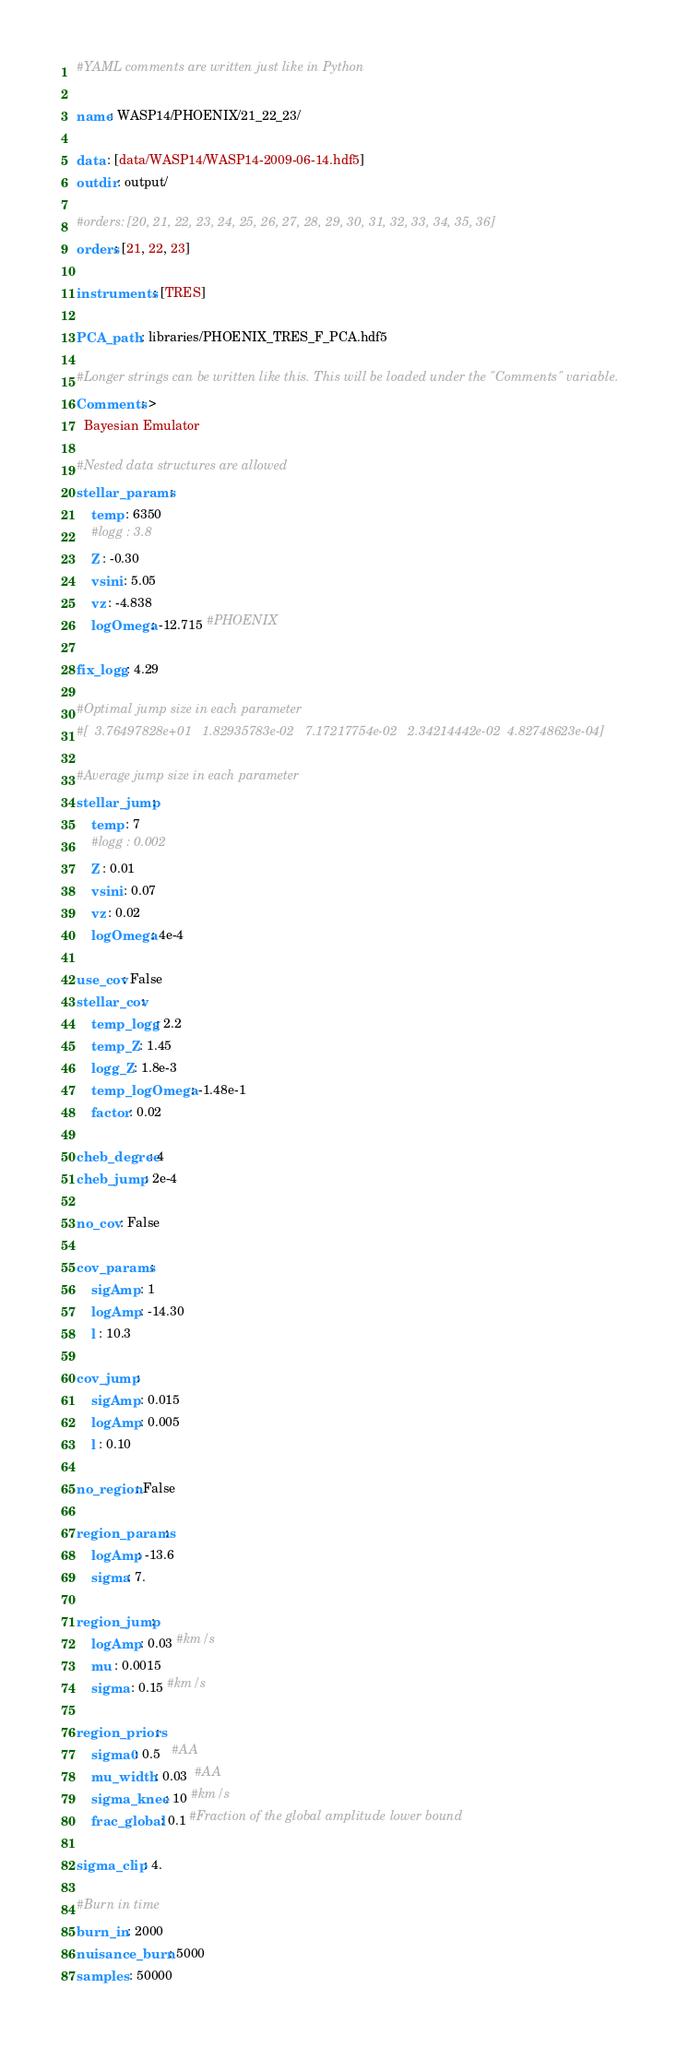<code> <loc_0><loc_0><loc_500><loc_500><_YAML_>#YAML comments are written just like in Python

name: WASP14/PHOENIX/21_22_23/

data : [data/WASP14/WASP14-2009-06-14.hdf5]
outdir : output/

#orders: [20, 21, 22, 23, 24, 25, 26, 27, 28, 29, 30, 31, 32, 33, 34, 35, 36]
orders: [21, 22, 23]

instruments : [TRES]

PCA_path : libraries/PHOENIX_TRES_F_PCA.hdf5

#Longer strings can be written like this. This will be loaded under the "Comments" variable.
Comments: >
  Bayesian Emulator

#Nested data structures are allowed
stellar_params :
    temp : 6350
    #logg : 3.8
    Z : -0.30
    vsini : 5.05
    vz : -4.838
    logOmega: -12.715 #PHOENIX

fix_logg : 4.29

#Optimal jump size in each parameter
#[  3.76497828e+01   1.82935783e-02   7.17217754e-02   2.34214442e-02  4.82748623e-04]

#Average jump size in each parameter
stellar_jump:
    temp : 7
    #logg : 0.002
    Z : 0.01
    vsini : 0.07
    vz : 0.02
    logOmega: 4e-4

use_cov: False
stellar_cov:
    temp_logg : 2.2
    temp_Z : 1.45
    logg_Z : 1.8e-3
    temp_logOmega : -1.48e-1
    factor : 0.02

cheb_degree: 4
cheb_jump : 2e-4

no_cov : False

cov_params :
    sigAmp : 1
    logAmp : -14.30
    l : 10.3

cov_jump :
    sigAmp : 0.015
    logAmp : 0.005
    l : 0.10

no_region: False

region_params:
    logAmp: -13.6
    sigma: 7.

region_jump:
    logAmp : 0.03 #km/s
    mu : 0.0015
    sigma : 0.15 #km/s

region_priors:
    sigma0: 0.5   #AA
    mu_width : 0.03  #AA
    sigma_knee : 10 #km/s
    frac_global : 0.1 #Fraction of the global amplitude lower bound

sigma_clip : 4.

#Burn in time
burn_in : 2000
nuisance_burn : 5000
samples : 50000
</code> 